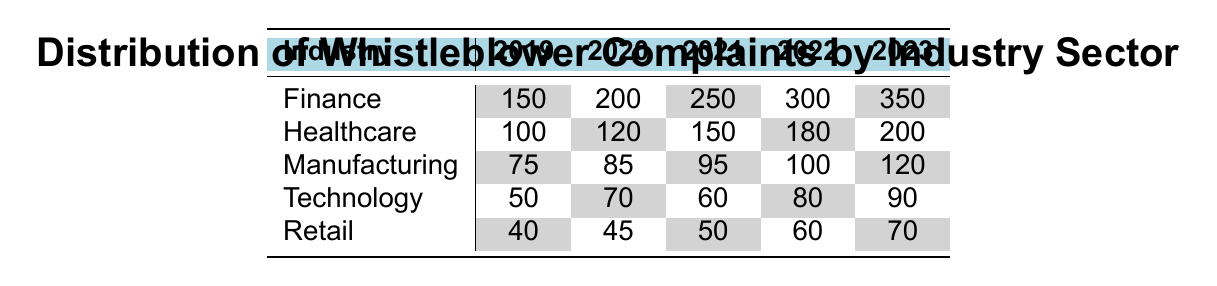What was the total number of whistleblower complaints in the Finance industry in 2021? According to the table, the Finance industry had 250 complaints in 2021.
Answer: 250 Which industry had the highest number of complaints in 2023? In 2023, the Finance industry had 350 complaints, which is higher than any other industry listed in the table.
Answer: Finance What was the percentage increase in complaints in the Healthcare industry from 2019 to 2022? The number of complaints in Healthcare increased from 100 in 2019 to 180 in 2022. The increase is 180 - 100 = 80 complaints. The percentage increase is calculated as (80/100) * 100 = 80%.
Answer: 80% Did the number of whistleblower complaints in the Retail industry ever exceed 60 from 2019 to 2023? Looking at the table, the Retail industry had complaints of 40 in 2019, 45 in 2020, 50 in 2021, 60 in 2022, and 70 in 2023. The highest number exceeded 60 but only in 2023.
Answer: Yes What is the average number of complaints in the Manufacturing industry over the five years? The complaints for Manufacturing over the years are: 75 (2019), 85 (2020), 95 (2021), 100 (2022), and 120 (2023). Summing these values gives 75 + 85 + 95 + 100 + 120 = 475. There are 5 years, so the average is 475 / 5 = 95.
Answer: 95 What was the total number of complaints across all industries in 2020? Adding the complaints in 2020 for all industries: Finance (200) + Healthcare (120) + Manufacturing (85) + Technology (70) + Retail (45) equals 200 + 120 + 85 + 70 + 45 = 520 complaints.
Answer: 520 In which year did the Technology industry have the least complaints? The table shows that the Technology industry had 50 complaints in 2019, 70 in 2020, 60 in 2021, 80 in 2022, and 90 in 2023. The least complaints were in 2019 with 50.
Answer: 2019 Was there a year when the Healthcare industry had more complaints than the Manufacturing industry? Yes, in the years 2020, 2021, 2022, and 2023, the Healthcare industry complaints (120, 150, 180, 200) were greater than those in Manufacturing (85, 95, 100, 120).
Answer: Yes What was the trend of complaints in the Finance industry over the five years? The complaints increased each year: 150 in 2019, 200 in 2020, 250 in 2021, 300 in 2022, and 350 in 2023, showing a clear upward trend.
Answer: Increasing 